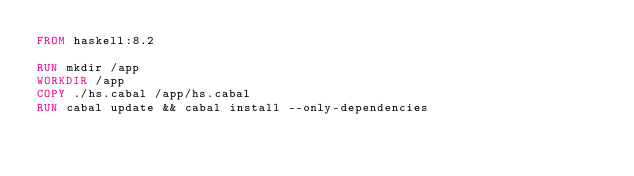Convert code to text. <code><loc_0><loc_0><loc_500><loc_500><_Dockerfile_>FROM haskell:8.2

RUN mkdir /app
WORKDIR /app
COPY ./hs.cabal /app/hs.cabal
RUN cabal update && cabal install --only-dependencies
</code> 